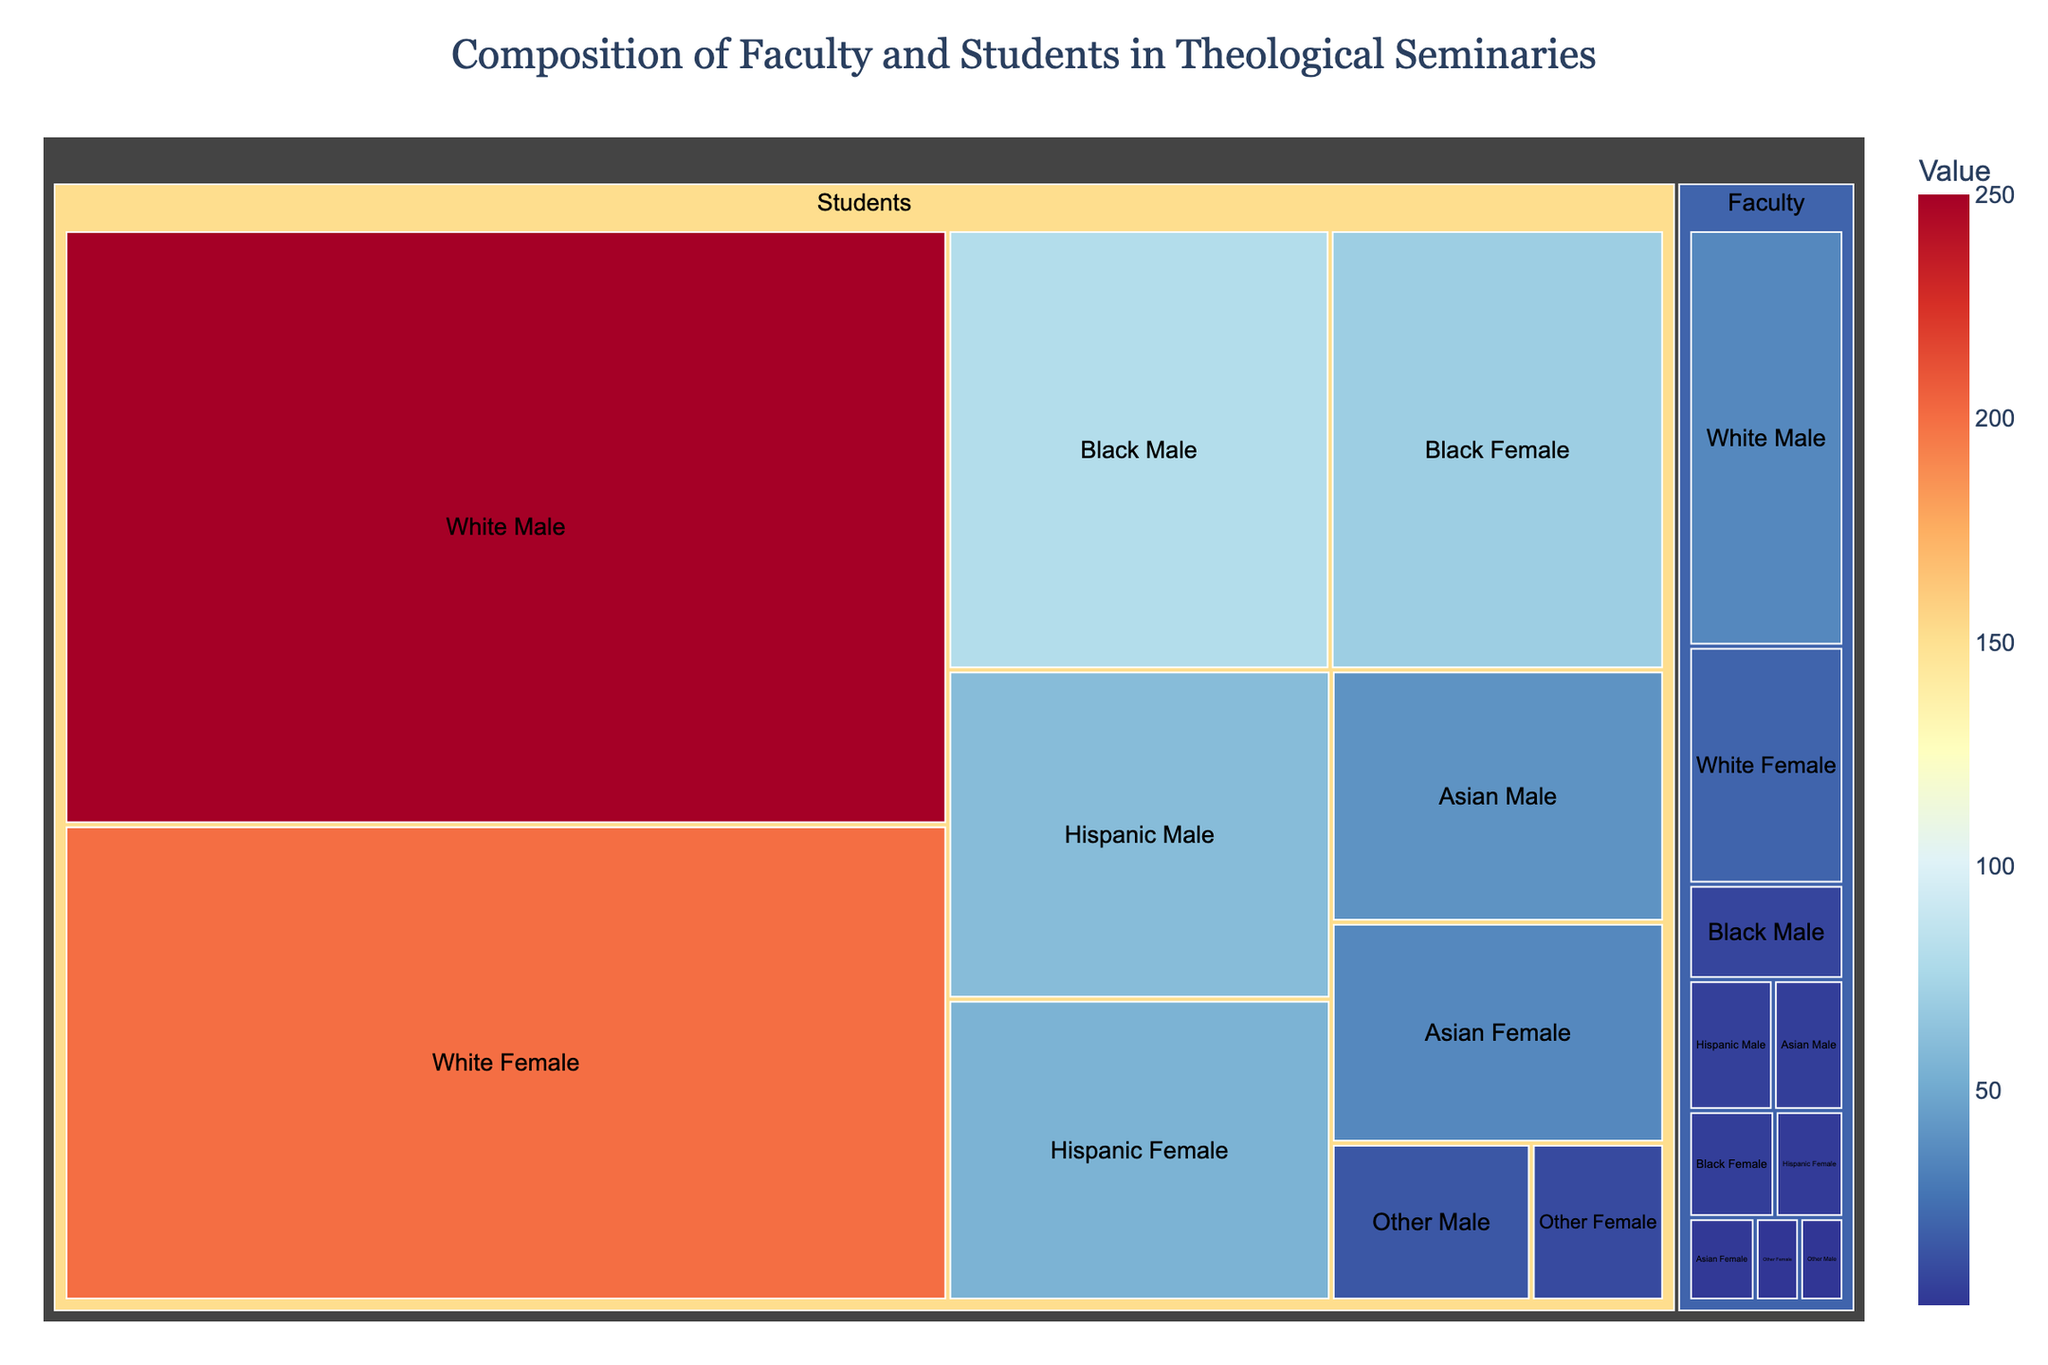what is the total number of faculty members represented in the figure? To find the total number of faculty members, sum the values for all faculty subcategories: 35 (White Male) + 20 (White Female) + 8 (Black Male) + 5 (Black Female) + 6 (Hispanic Male) + 4 (Hispanic Female) + 5 (Asian Male) + 3 (Asian Female) + 2 (Other Male) + 2 (Other Female) = 90
Answer: 90 How many more White Male students are there compared to Black Male students? Subtract the number of Black Male students from the number of White Male students: 250 (White Male) - 80 (Black Male) = 170
Answer: 170 What is the combined proportion of Hispanic and Asian Female students among the total number of female students? First, find the total number of female students: 200 (White Female) + 70 (Black Female) + 55 (Hispanic Female) + 35 (Asian Female) + 10 (Other Female) = 370. Then, sum the number of Hispanic and Asian Female students: 55 (Hispanic Female) + 35 (Asian Female) = 90. Finally, calculate the proportion: 90 / 370 ≈ 0.243 or 24.3%
Answer: 24.3% Which ethnic group among faculty members has the smallest representation, and what is its count? The "Other Male" and "Other Female" subcategories have the smallest counts with 2 each, making "Other" the least represented ethnic group among faculty members.
Answer: 2 Are there more Hispanic Male students or Hispanic Female students? Compare the number of Hispanic Male students (60) to the number of Hispanic Female students (55).
Answer: Hispanic Male How does the representation of Asian faculty members compare to that of Hispanic faculty members? Sum the counts for each group: 5 (Asian Male) + 3 (Asian Female) = 8 for Asian faculty, and 6 (Hispanic Male) + 4 (Hispanic Female) = 10 for Hispanic faculty.
Answer: Hispanic faculty What is the overall number of students in the seminary as represented in the figure? Sum the values for all student subcategories: 250 (White Male) + 200 (White Female) + 80 (Black Male) + 70 (Black Female) + 60 (Hispanic Male) + 55 (Hispanic Female) + 40 (Asian Male) + 35 (Asian Female) + 15 (Other Male) + 10 (Other Female) = 815
Answer: 815 In the figure, which gender has more representation among Black faculty members? Compare the number of Black Male faculty members (8) to Black Female faculty members (5).
Answer: Male What is the difference in the total number of male and female students? Sum the number of male students: 250 (White) + 80 (Black) + 60 (Hispanic) + 40 (Asian) + 15 (Other) = 445. Sum the number of female students: 200 (White) + 70 (Black) + 55 (Hispanic) + 35 (Asian) + 10 (Other) = 370. Find the difference: 445 - 370 = 75
Answer: 75 What percentage of faculty members are Black? Find the total number of Black faculty members: 8 (Black Male) + 5 (Black Female) = 13. Calculate the percentage: (13 / 90) * 100 ≈ 14.44%
Answer: 14.4% 